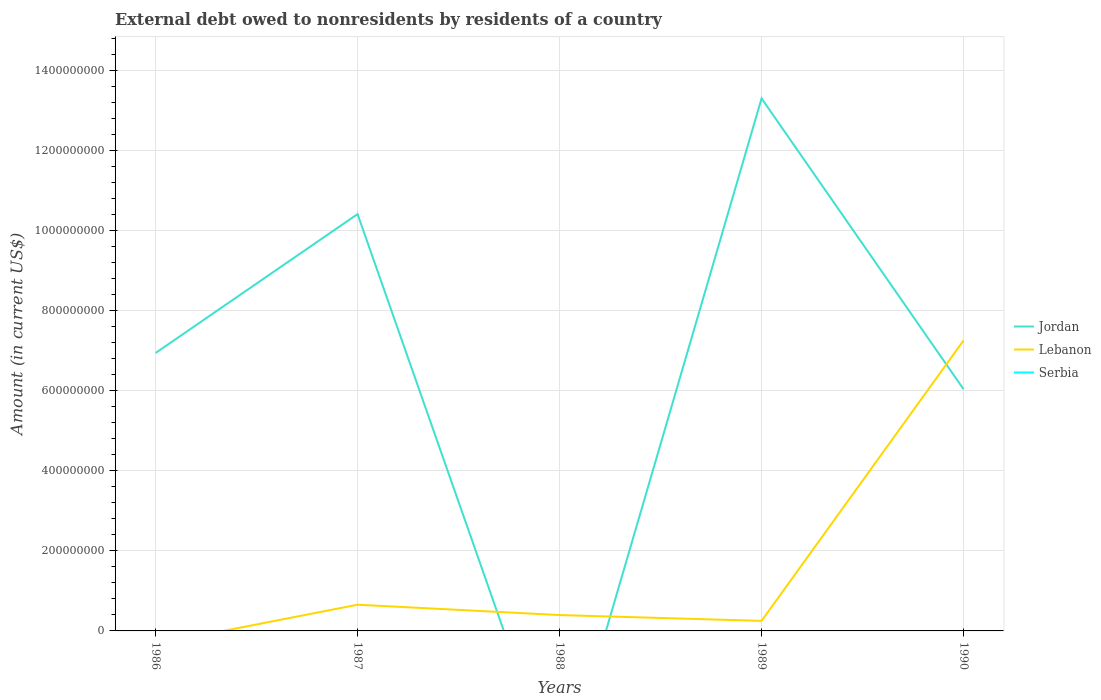What is the total external debt owed by residents in Lebanon in the graph?
Offer a terse response. -7.01e+08. What is the difference between the highest and the second highest external debt owed by residents in Lebanon?
Your answer should be compact. 7.26e+08. How many lines are there?
Your response must be concise. 2. How many years are there in the graph?
Provide a short and direct response. 5. Are the values on the major ticks of Y-axis written in scientific E-notation?
Your response must be concise. No. Does the graph contain any zero values?
Keep it short and to the point. Yes. How many legend labels are there?
Keep it short and to the point. 3. How are the legend labels stacked?
Provide a succinct answer. Vertical. What is the title of the graph?
Offer a very short reply. External debt owed to nonresidents by residents of a country. Does "Oman" appear as one of the legend labels in the graph?
Your answer should be compact. No. What is the label or title of the Y-axis?
Your response must be concise. Amount (in current US$). What is the Amount (in current US$) of Jordan in 1986?
Provide a succinct answer. 6.94e+08. What is the Amount (in current US$) of Jordan in 1987?
Ensure brevity in your answer.  1.04e+09. What is the Amount (in current US$) in Lebanon in 1987?
Provide a succinct answer. 6.55e+07. What is the Amount (in current US$) in Lebanon in 1988?
Keep it short and to the point. 3.96e+07. What is the Amount (in current US$) of Jordan in 1989?
Provide a succinct answer. 1.33e+09. What is the Amount (in current US$) of Lebanon in 1989?
Your answer should be compact. 2.51e+07. What is the Amount (in current US$) of Serbia in 1989?
Your answer should be very brief. 0. What is the Amount (in current US$) of Jordan in 1990?
Provide a succinct answer. 6.04e+08. What is the Amount (in current US$) of Lebanon in 1990?
Keep it short and to the point. 7.26e+08. Across all years, what is the maximum Amount (in current US$) in Jordan?
Provide a succinct answer. 1.33e+09. Across all years, what is the maximum Amount (in current US$) in Lebanon?
Provide a succinct answer. 7.26e+08. Across all years, what is the minimum Amount (in current US$) in Lebanon?
Your response must be concise. 0. What is the total Amount (in current US$) of Jordan in the graph?
Provide a short and direct response. 3.67e+09. What is the total Amount (in current US$) of Lebanon in the graph?
Ensure brevity in your answer.  8.56e+08. What is the total Amount (in current US$) of Serbia in the graph?
Your answer should be compact. 0. What is the difference between the Amount (in current US$) of Jordan in 1986 and that in 1987?
Offer a very short reply. -3.47e+08. What is the difference between the Amount (in current US$) in Jordan in 1986 and that in 1989?
Ensure brevity in your answer.  -6.36e+08. What is the difference between the Amount (in current US$) in Jordan in 1986 and that in 1990?
Provide a short and direct response. 9.05e+07. What is the difference between the Amount (in current US$) of Lebanon in 1987 and that in 1988?
Keep it short and to the point. 2.59e+07. What is the difference between the Amount (in current US$) in Jordan in 1987 and that in 1989?
Make the answer very short. -2.89e+08. What is the difference between the Amount (in current US$) of Lebanon in 1987 and that in 1989?
Provide a short and direct response. 4.04e+07. What is the difference between the Amount (in current US$) in Jordan in 1987 and that in 1990?
Offer a very short reply. 4.38e+08. What is the difference between the Amount (in current US$) of Lebanon in 1987 and that in 1990?
Your answer should be compact. -6.60e+08. What is the difference between the Amount (in current US$) of Lebanon in 1988 and that in 1989?
Keep it short and to the point. 1.45e+07. What is the difference between the Amount (in current US$) in Lebanon in 1988 and that in 1990?
Ensure brevity in your answer.  -6.86e+08. What is the difference between the Amount (in current US$) of Jordan in 1989 and that in 1990?
Your answer should be compact. 7.27e+08. What is the difference between the Amount (in current US$) in Lebanon in 1989 and that in 1990?
Offer a very short reply. -7.01e+08. What is the difference between the Amount (in current US$) in Jordan in 1986 and the Amount (in current US$) in Lebanon in 1987?
Offer a terse response. 6.29e+08. What is the difference between the Amount (in current US$) in Jordan in 1986 and the Amount (in current US$) in Lebanon in 1988?
Provide a succinct answer. 6.55e+08. What is the difference between the Amount (in current US$) of Jordan in 1986 and the Amount (in current US$) of Lebanon in 1989?
Provide a short and direct response. 6.69e+08. What is the difference between the Amount (in current US$) of Jordan in 1986 and the Amount (in current US$) of Lebanon in 1990?
Ensure brevity in your answer.  -3.13e+07. What is the difference between the Amount (in current US$) in Jordan in 1987 and the Amount (in current US$) in Lebanon in 1988?
Offer a terse response. 1.00e+09. What is the difference between the Amount (in current US$) in Jordan in 1987 and the Amount (in current US$) in Lebanon in 1989?
Keep it short and to the point. 1.02e+09. What is the difference between the Amount (in current US$) of Jordan in 1987 and the Amount (in current US$) of Lebanon in 1990?
Offer a terse response. 3.16e+08. What is the difference between the Amount (in current US$) in Jordan in 1989 and the Amount (in current US$) in Lebanon in 1990?
Offer a terse response. 6.05e+08. What is the average Amount (in current US$) of Jordan per year?
Ensure brevity in your answer.  7.34e+08. What is the average Amount (in current US$) in Lebanon per year?
Give a very brief answer. 1.71e+08. In the year 1987, what is the difference between the Amount (in current US$) of Jordan and Amount (in current US$) of Lebanon?
Keep it short and to the point. 9.76e+08. In the year 1989, what is the difference between the Amount (in current US$) of Jordan and Amount (in current US$) of Lebanon?
Your answer should be very brief. 1.31e+09. In the year 1990, what is the difference between the Amount (in current US$) in Jordan and Amount (in current US$) in Lebanon?
Provide a succinct answer. -1.22e+08. What is the ratio of the Amount (in current US$) in Jordan in 1986 to that in 1987?
Your answer should be very brief. 0.67. What is the ratio of the Amount (in current US$) of Jordan in 1986 to that in 1989?
Offer a very short reply. 0.52. What is the ratio of the Amount (in current US$) in Jordan in 1986 to that in 1990?
Provide a succinct answer. 1.15. What is the ratio of the Amount (in current US$) in Lebanon in 1987 to that in 1988?
Ensure brevity in your answer.  1.65. What is the ratio of the Amount (in current US$) of Jordan in 1987 to that in 1989?
Make the answer very short. 0.78. What is the ratio of the Amount (in current US$) in Lebanon in 1987 to that in 1989?
Provide a short and direct response. 2.61. What is the ratio of the Amount (in current US$) in Jordan in 1987 to that in 1990?
Provide a short and direct response. 1.72. What is the ratio of the Amount (in current US$) of Lebanon in 1987 to that in 1990?
Your answer should be very brief. 0.09. What is the ratio of the Amount (in current US$) in Lebanon in 1988 to that in 1989?
Ensure brevity in your answer.  1.58. What is the ratio of the Amount (in current US$) of Lebanon in 1988 to that in 1990?
Provide a succinct answer. 0.05. What is the ratio of the Amount (in current US$) of Jordan in 1989 to that in 1990?
Make the answer very short. 2.2. What is the ratio of the Amount (in current US$) of Lebanon in 1989 to that in 1990?
Give a very brief answer. 0.03. What is the difference between the highest and the second highest Amount (in current US$) of Jordan?
Keep it short and to the point. 2.89e+08. What is the difference between the highest and the second highest Amount (in current US$) of Lebanon?
Provide a short and direct response. 6.60e+08. What is the difference between the highest and the lowest Amount (in current US$) in Jordan?
Provide a short and direct response. 1.33e+09. What is the difference between the highest and the lowest Amount (in current US$) in Lebanon?
Give a very brief answer. 7.26e+08. 